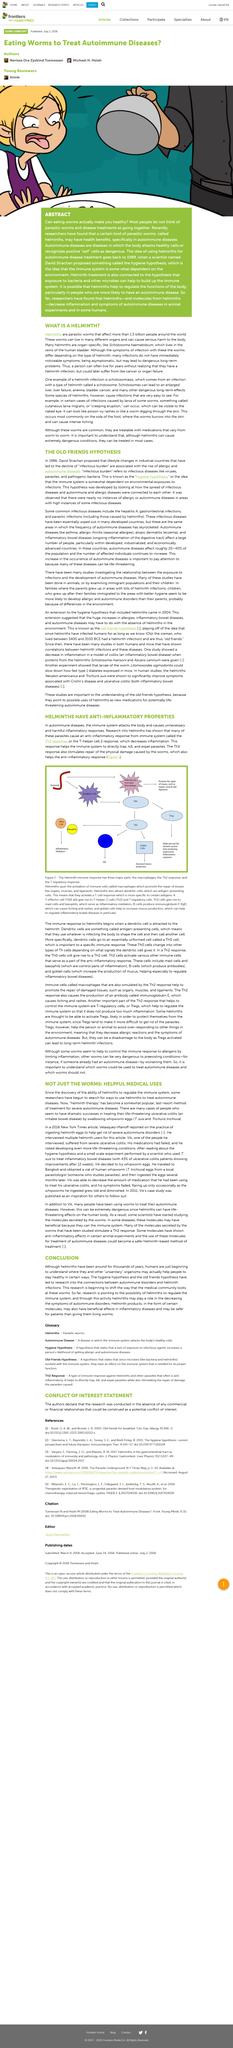Point out several critical features in this image. Helminth eggs have been shown to be effective in the treatment of autoimmune diseases and disorders. Yes, Helminth can cause serious harm to the body. In 2011, Vik's case study was published. Goblet cells play a crucial role in increasing mucus production in the body. Ulcerative colitis is a life-threatening disease that can be treated with the help of whipworm eggs. 